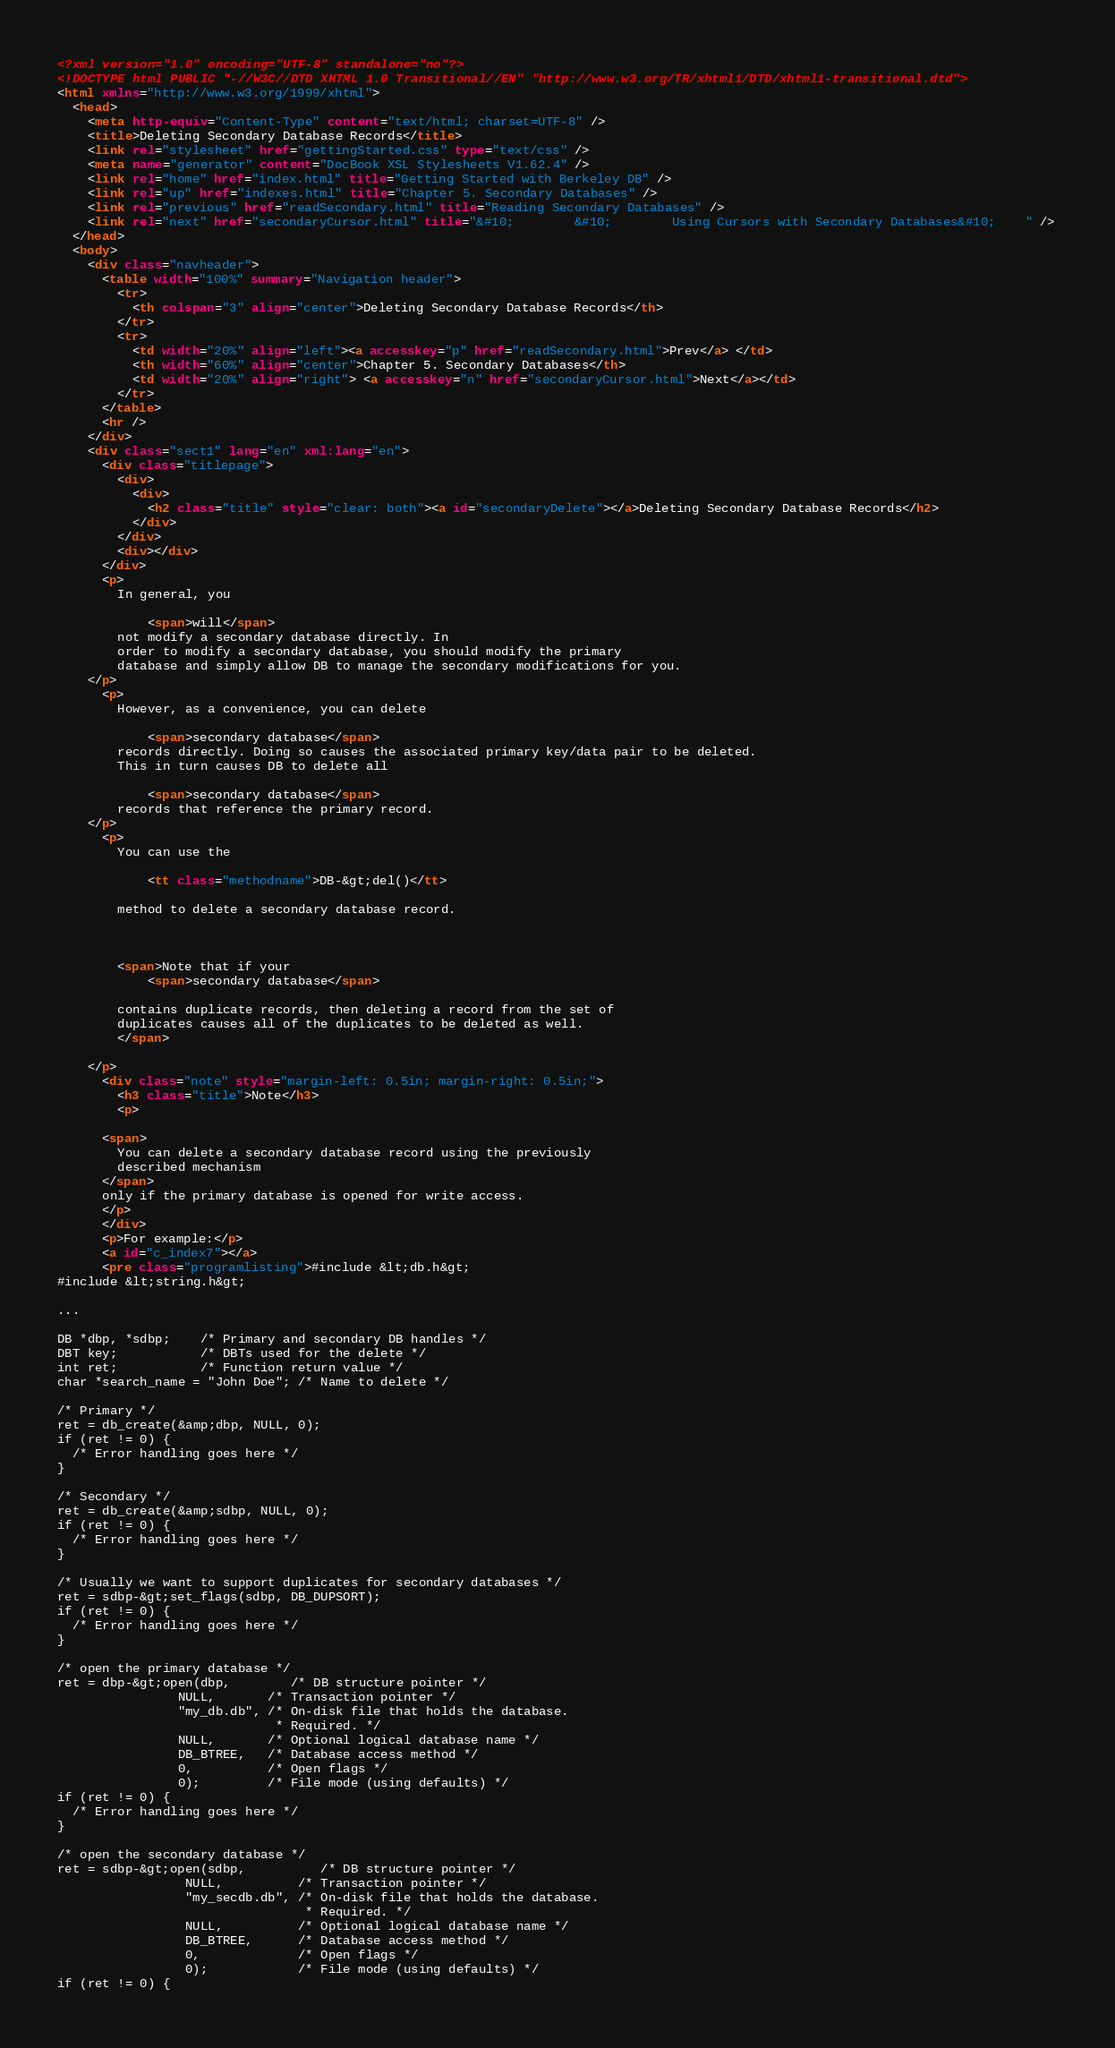Convert code to text. <code><loc_0><loc_0><loc_500><loc_500><_HTML_><?xml version="1.0" encoding="UTF-8" standalone="no"?>
<!DOCTYPE html PUBLIC "-//W3C//DTD XHTML 1.0 Transitional//EN" "http://www.w3.org/TR/xhtml1/DTD/xhtml1-transitional.dtd">
<html xmlns="http://www.w3.org/1999/xhtml">
  <head>
    <meta http-equiv="Content-Type" content="text/html; charset=UTF-8" />
    <title>Deleting Secondary Database Records</title>
    <link rel="stylesheet" href="gettingStarted.css" type="text/css" />
    <meta name="generator" content="DocBook XSL Stylesheets V1.62.4" />
    <link rel="home" href="index.html" title="Getting Started with Berkeley DB" />
    <link rel="up" href="indexes.html" title="Chapter 5. Secondary Databases" />
    <link rel="previous" href="readSecondary.html" title="Reading Secondary Databases" />
    <link rel="next" href="secondaryCursor.html" title="&#10;        &#10;        Using Cursors with Secondary Databases&#10;    " />
  </head>
  <body>
    <div class="navheader">
      <table width="100%" summary="Navigation header">
        <tr>
          <th colspan="3" align="center">Deleting Secondary Database Records</th>
        </tr>
        <tr>
          <td width="20%" align="left"><a accesskey="p" href="readSecondary.html">Prev</a> </td>
          <th width="60%" align="center">Chapter 5. Secondary Databases</th>
          <td width="20%" align="right"> <a accesskey="n" href="secondaryCursor.html">Next</a></td>
        </tr>
      </table>
      <hr />
    </div>
    <div class="sect1" lang="en" xml:lang="en">
      <div class="titlepage">
        <div>
          <div>
            <h2 class="title" style="clear: both"><a id="secondaryDelete"></a>Deleting Secondary Database Records</h2>
          </div>
        </div>
        <div></div>
      </div>
      <p>
        In general, you 
             
            <span>will</span> 
        not modify a secondary database directly. In
        order to modify a secondary database, you should modify the primary
        database and simply allow DB to manage the secondary modifications for you.
    </p>
      <p>
        However, as a convenience, you can delete 
            
            <span>secondary database</span>
        records directly. Doing so causes the associated primary key/data pair to be deleted.
        This in turn causes DB to delete all 
            
            <span>secondary database</span>
        records that reference the primary record.
    </p>
      <p>
        You can use the 
            
            <tt class="methodname">DB-&gt;del()</tt>
            
        method to delete a secondary database record. 
        
        

        <span>Note that if your
            <span>secondary database</span> 
             
        contains duplicate records, then deleting a record from the set of
        duplicates causes all of the duplicates to be deleted as well.
        </span>

    </p>
      <div class="note" style="margin-left: 0.5in; margin-right: 0.5in;">
        <h3 class="title">Note</h3>
        <p>
      
      <span>
        You can delete a secondary database record using the previously
        described mechanism
      </span>
      only if the primary database is opened for write access.
      </p>
      </div>
      <p>For example:</p>
      <a id="c_index7"></a>
      <pre class="programlisting">#include &lt;db.h&gt;
#include &lt;string.h&gt;
                                                                                                                                     
...
                                                                                                                                     
DB *dbp, *sdbp;    /* Primary and secondary DB handles */
DBT key;           /* DBTs used for the delete */
int ret;           /* Function return value */
char *search_name = "John Doe"; /* Name to delete */

/* Primary */
ret = db_create(&amp;dbp, NULL, 0);
if (ret != 0) {
  /* Error handling goes here */
}
                                                                                                                                     
/* Secondary */
ret = db_create(&amp;sdbp, NULL, 0);
if (ret != 0) {
  /* Error handling goes here */
}

/* Usually we want to support duplicates for secondary databases */
ret = sdbp-&gt;set_flags(sdbp, DB_DUPSORT);
if (ret != 0) {
  /* Error handling goes here */
}

/* open the primary database */
ret = dbp-&gt;open(dbp,        /* DB structure pointer */
                NULL,       /* Transaction pointer */
                "my_db.db", /* On-disk file that holds the database.
                             * Required. */
                NULL,       /* Optional logical database name */
                DB_BTREE,   /* Database access method */
                0,          /* Open flags */
                0);         /* File mode (using defaults) */
if (ret != 0) {
  /* Error handling goes here */
}

/* open the secondary database */
ret = sdbp-&gt;open(sdbp,          /* DB structure pointer */
                 NULL,          /* Transaction pointer */
                 "my_secdb.db", /* On-disk file that holds the database.
                                 * Required. */
                 NULL,          /* Optional logical database name */
                 DB_BTREE,      /* Database access method */
                 0,             /* Open flags */
                 0);            /* File mode (using defaults) */
if (ret != 0) {</code> 